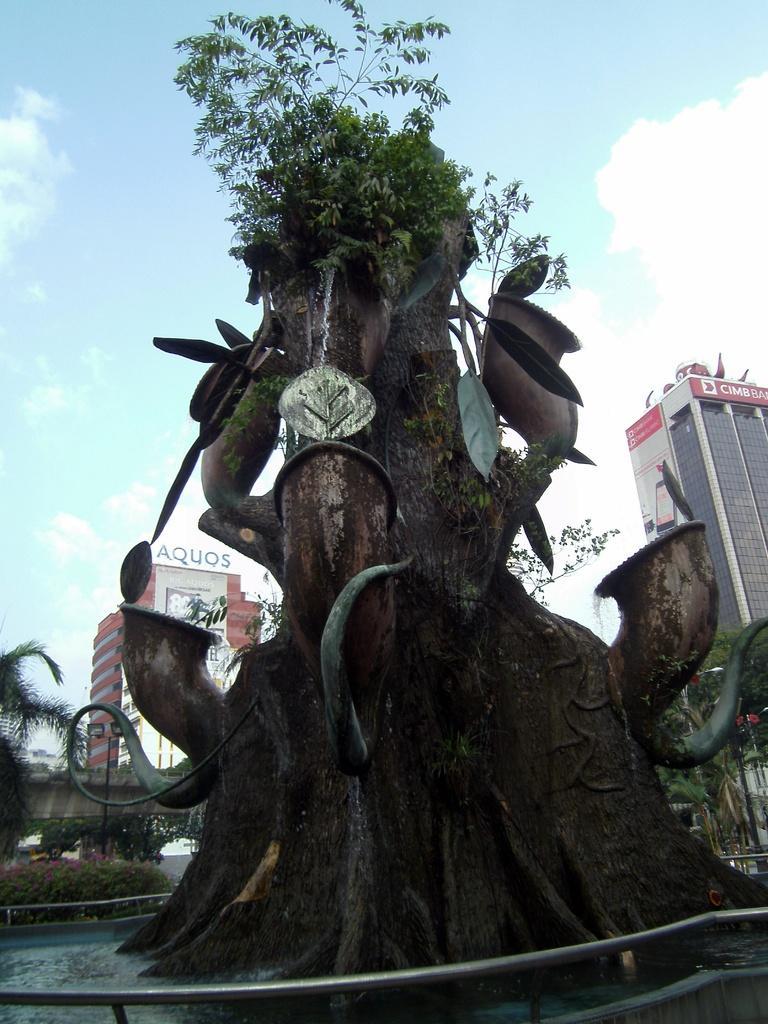In one or two sentences, can you explain what this image depicts? In the foreground of the picture there is a tree, on the tree there are sculptures. In the background there are trees, buildings and other objects. In the foreground there is railing. Sky is partially cloudy. 